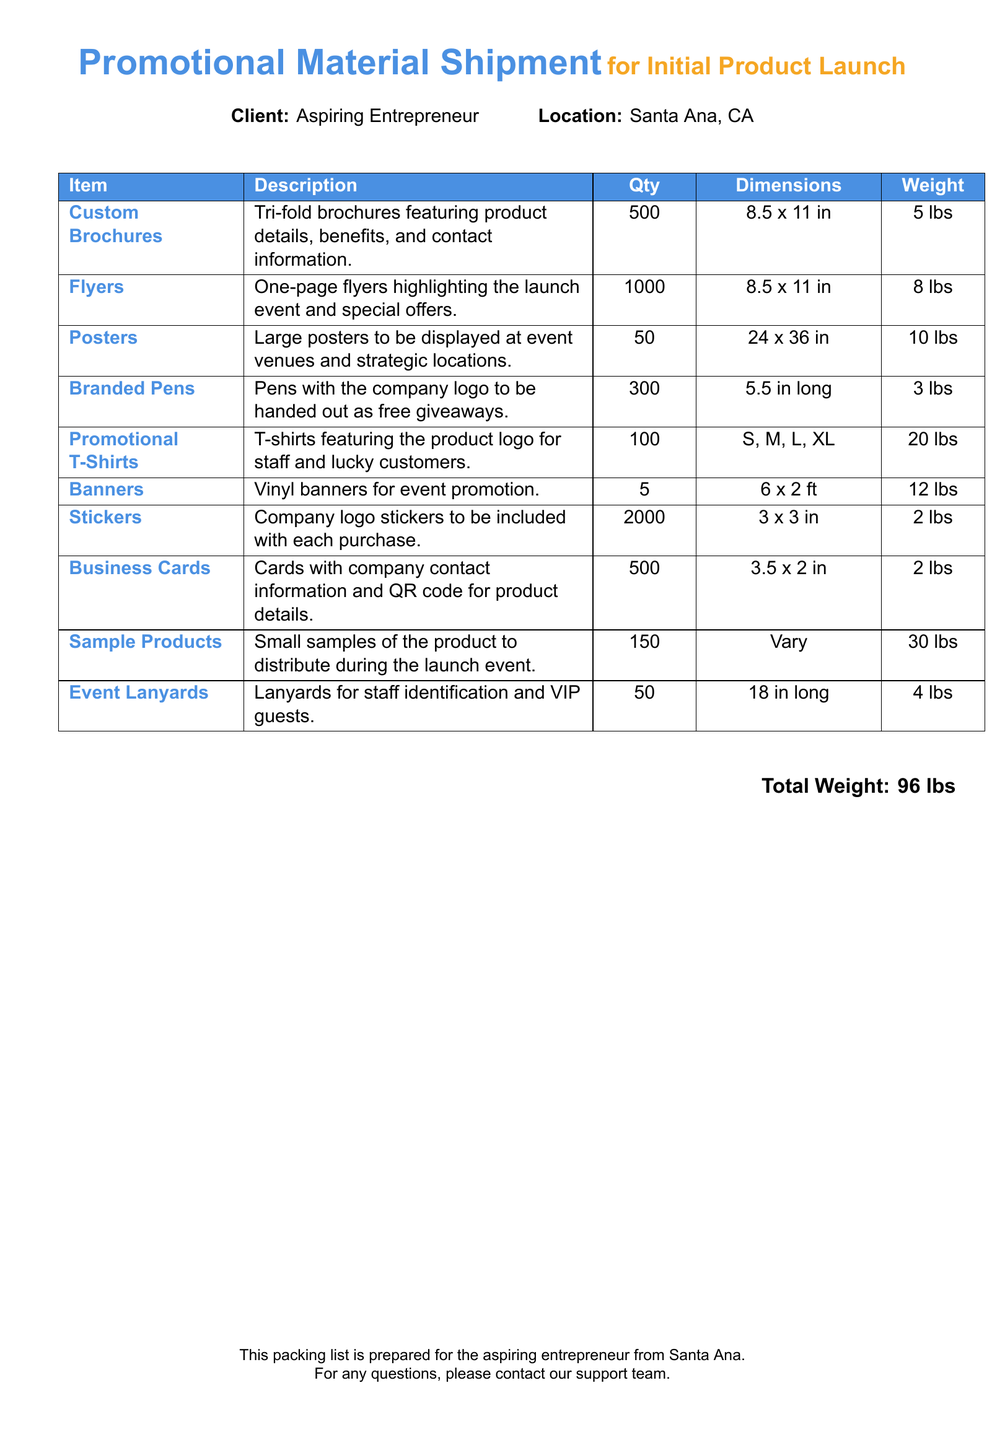What is the client name? The client's name is specified in the document as "Aspiring Entrepreneur."
Answer: Aspiring Entrepreneur What is the total weight of the shipment? The total weight is clearly stated at the bottom of the document.
Answer: 96 lbs How many Custom Brochures are included? The quantity of Custom Brochures is listed in the packing list section.
Answer: 500 What is the dimension of the Posters? The dimensions of the Posters are provided in the list.
Answer: 24 x 36 in Which item has the highest weight? Comparing the weights of all items, Sample Products have the highest weight.
Answer: 30 lbs How many Branded Pens are there? The quantity of Branded Pens is stated in the document.
Answer: 300 What type of promotional items are provided for giveaways? The document specifies the type of promotional items for giveaways.
Answer: Branded Pens How many Flyers will be available? The number of Flyers is mentioned in the packing list.
Answer: 1000 What is the purpose of the Business Cards? The document indicates the purpose of the Business Cards.
Answer: Company contact information and QR code for product details 